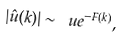Convert formula to latex. <formula><loc_0><loc_0><loc_500><loc_500>| \hat { u } ( k ) | \sim \ u e ^ { - F ( k ) } ,</formula> 